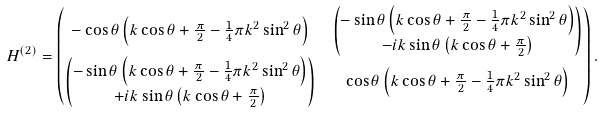<formula> <loc_0><loc_0><loc_500><loc_500>H ^ { ( 2 ) } & = \begin{pmatrix} - \cos \theta \left ( k \cos \theta + \frac { \pi } { 2 } - \frac { 1 } { 4 } \pi k ^ { 2 } \sin ^ { 2 } \theta \right ) & \begin{pmatrix} - \sin \theta \left ( k \cos \theta + \frac { \pi } { 2 } - \frac { 1 } { 4 } \pi k ^ { 2 } \sin ^ { 2 } \theta \right ) \\ - i k \sin \theta \left ( k \cos \theta + \frac { \pi } { 2 } \right ) \end{pmatrix} \\ \begin{pmatrix} - \sin \theta \left ( k \cos \theta + \frac { \pi } { 2 } - \frac { 1 } { 4 } \pi k ^ { 2 } \sin ^ { 2 } \theta \right ) \\ + i k \sin \theta \left ( k \cos \theta + \frac { \pi } { 2 } \right ) \end{pmatrix} & \cos \theta \left ( k \cos \theta + \frac { \pi } { 2 } - \frac { 1 } { 4 } \pi k ^ { 2 } \sin ^ { 2 } \theta \right ) \end{pmatrix} .</formula> 